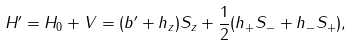Convert formula to latex. <formula><loc_0><loc_0><loc_500><loc_500>H ^ { \prime } = H _ { 0 } + V = ( b ^ { \prime } + h _ { z } ) S _ { z } + \frac { 1 } { 2 } ( h _ { + } S _ { - } + h _ { - } S _ { + } ) ,</formula> 